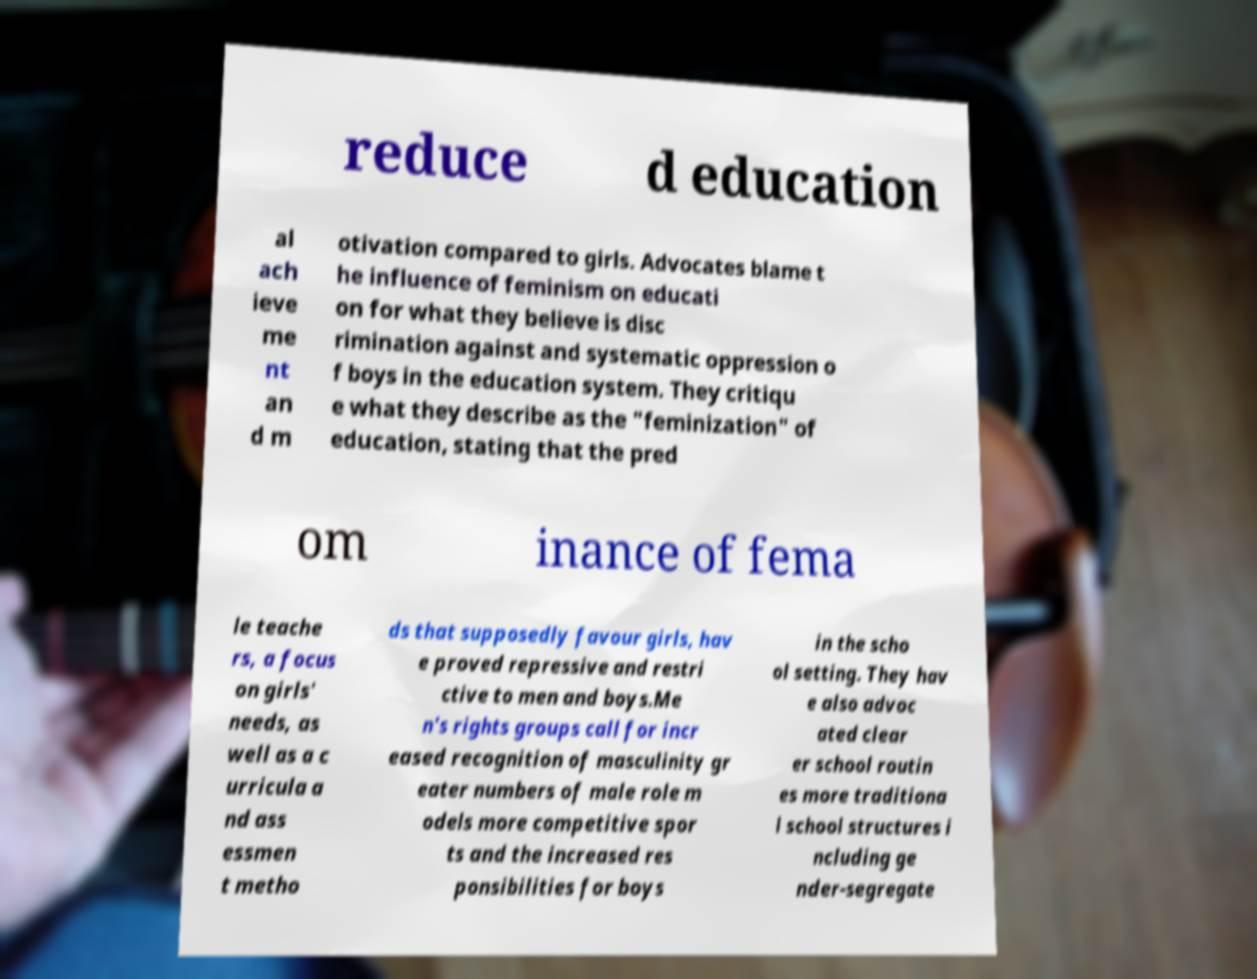Could you extract and type out the text from this image? reduce d education al ach ieve me nt an d m otivation compared to girls. Advocates blame t he influence of feminism on educati on for what they believe is disc rimination against and systematic oppression o f boys in the education system. They critiqu e what they describe as the "feminization" of education, stating that the pred om inance of fema le teache rs, a focus on girls' needs, as well as a c urricula a nd ass essmen t metho ds that supposedly favour girls, hav e proved repressive and restri ctive to men and boys.Me n's rights groups call for incr eased recognition of masculinity gr eater numbers of male role m odels more competitive spor ts and the increased res ponsibilities for boys in the scho ol setting. They hav e also advoc ated clear er school routin es more traditiona l school structures i ncluding ge nder-segregate 